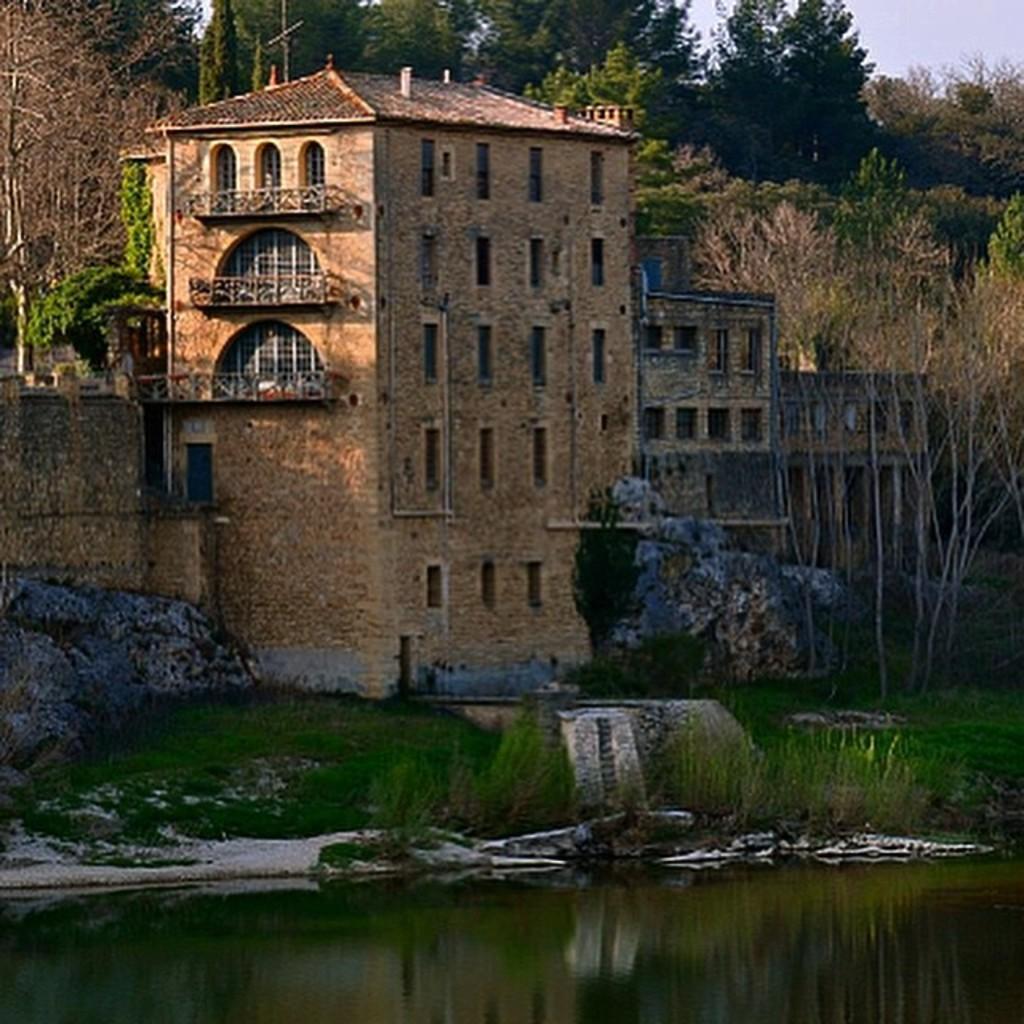Can you describe this image briefly? In this image I can see the water and the grass in front and I can also see the rocks. In the background I can see a building, number of trees and the sky. 